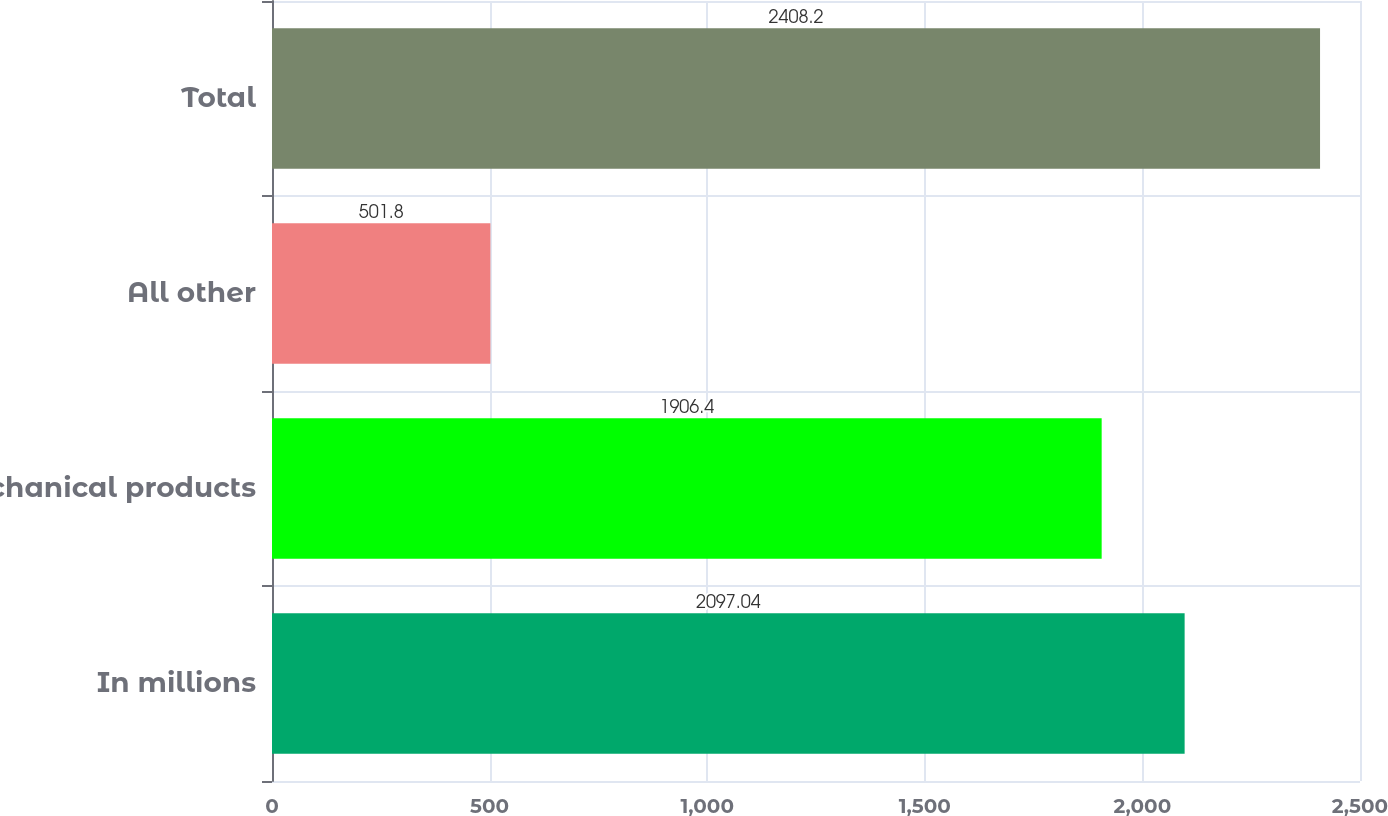<chart> <loc_0><loc_0><loc_500><loc_500><bar_chart><fcel>In millions<fcel>Mechanical products<fcel>All other<fcel>Total<nl><fcel>2097.04<fcel>1906.4<fcel>501.8<fcel>2408.2<nl></chart> 